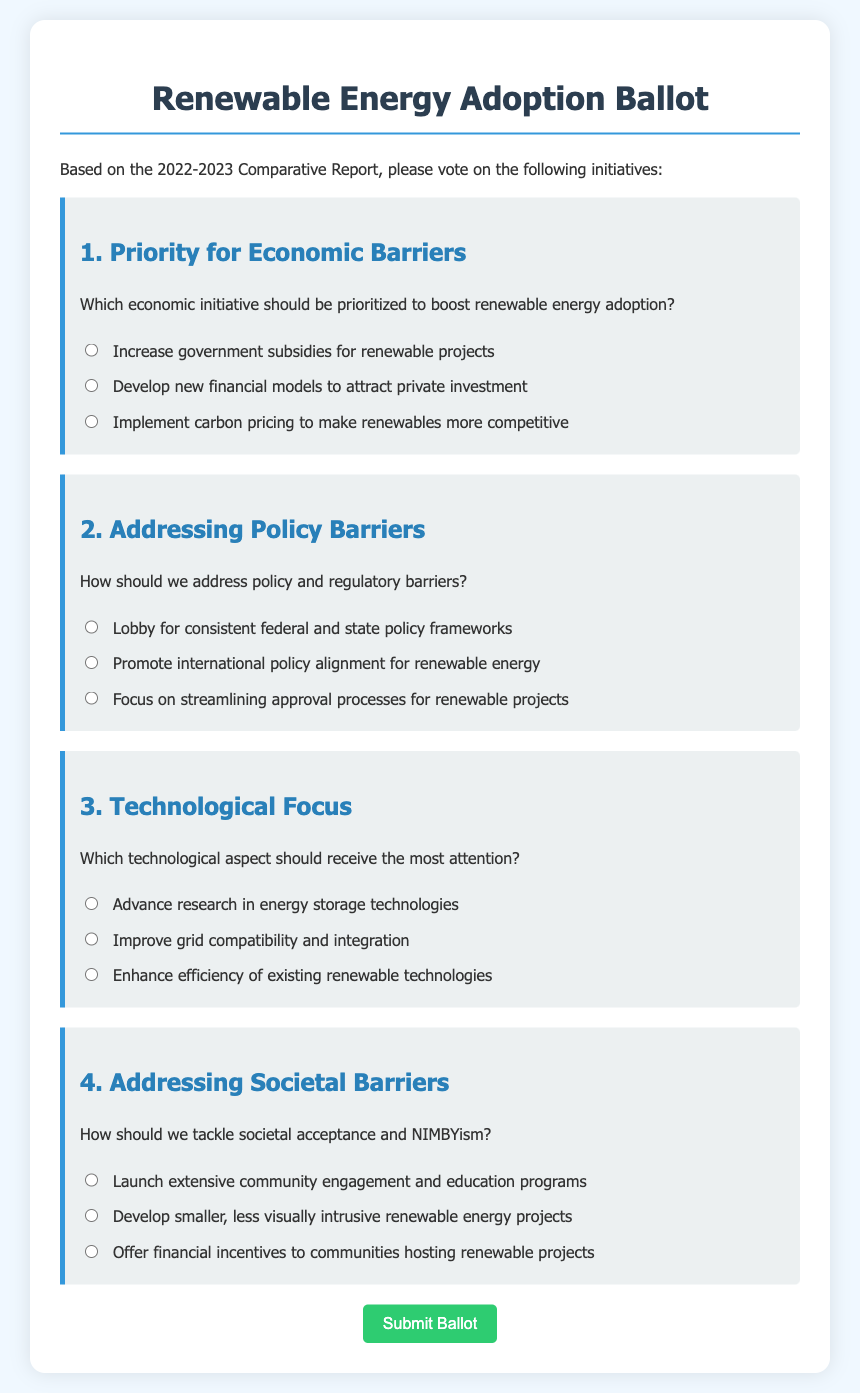What is the title of the ballot? The title of the ballot, which is presented at the top of the document, is "Renewable Energy Adoption Ballot."
Answer: Renewable Energy Adoption Ballot How many priority initiatives are listed for economic barriers? The document lists three initiatives under the economic barriers question.
Answer: 3 What color is used for the question backgrounds? The background color of the questions is a light grey, specifically noted as "#ecf0f1" in the document.
Answer: Light grey Which technological aspect focuses on energy storage innovation? The initiative that focuses on energy storage innovation is "Advance research in energy storage technologies."
Answer: Advance research in energy storage technologies How should we tackle societal acceptance? The suggestions listed include "Launch extensive community engagement and education programs," referring to how to tackle societal acceptance.
Answer: Launch extensive community engagement and education programs What is the emphasis of the second question? The second question emphasizes addressing policy and regulatory barriers in the context of renewable energy.
Answer: Addressing policy and regulatory barriers How many options are provided for addressing societal barriers? There are three options provided in the document for tackling societal barriers.
Answer: 3 What is the color of the submit button? The submit button is styled with a green color, specifically noted as "#2ecc71."
Answer: Green 